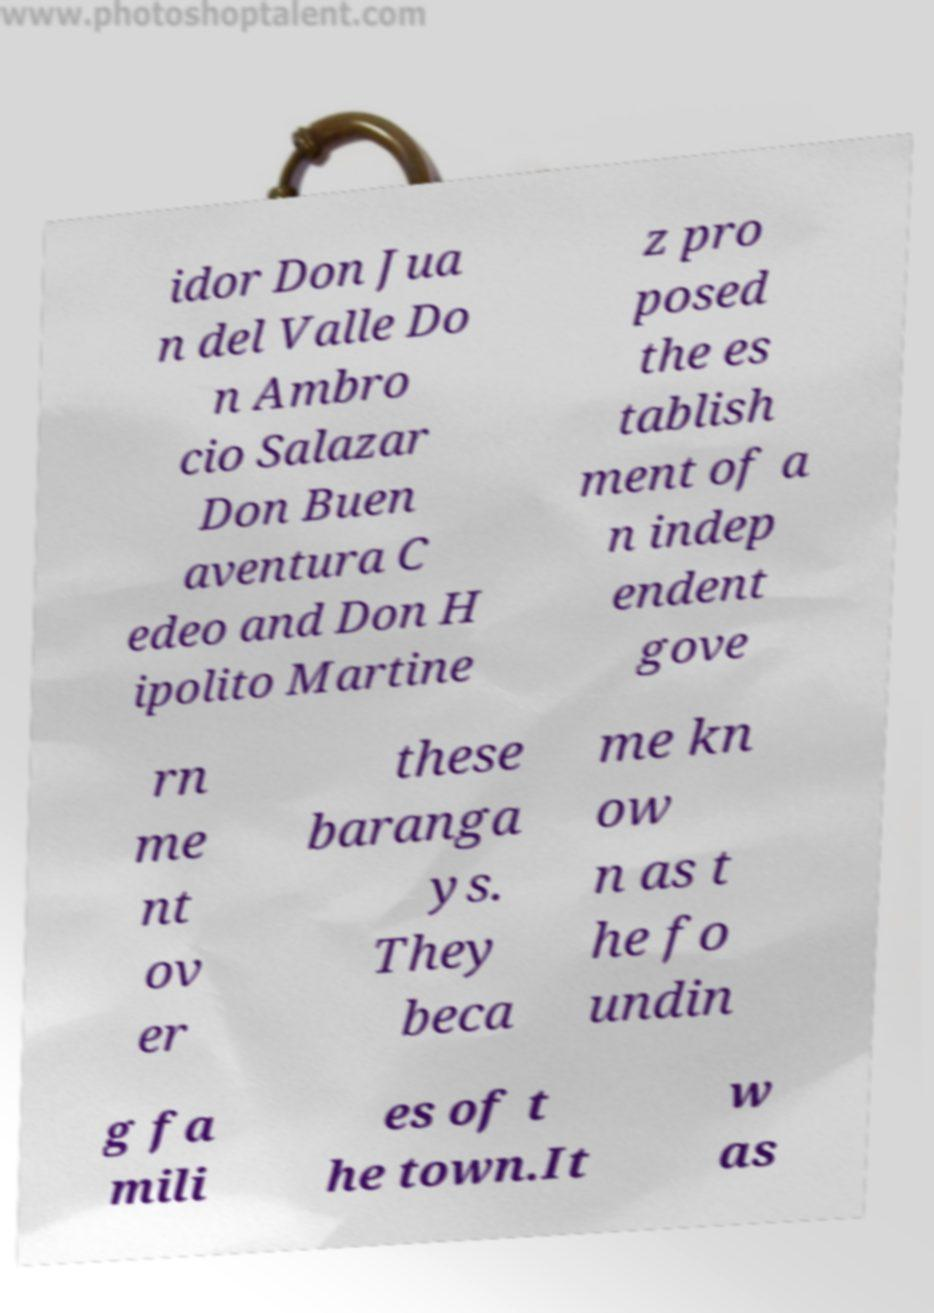For documentation purposes, I need the text within this image transcribed. Could you provide that? idor Don Jua n del Valle Do n Ambro cio Salazar Don Buen aventura C edeo and Don H ipolito Martine z pro posed the es tablish ment of a n indep endent gove rn me nt ov er these baranga ys. They beca me kn ow n as t he fo undin g fa mili es of t he town.It w as 